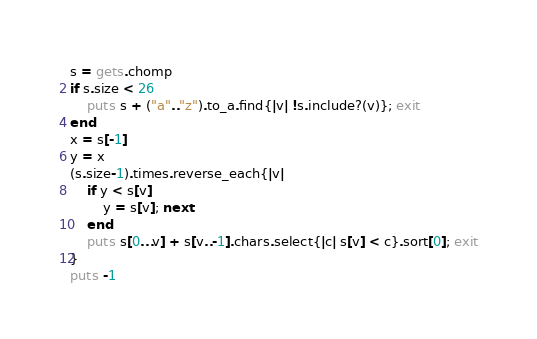<code> <loc_0><loc_0><loc_500><loc_500><_Ruby_>s = gets.chomp
if s.size < 26
    puts s + ("a".."z").to_a.find{|v| !s.include?(v)}; exit
end
x = s[-1]
y = x
(s.size-1).times.reverse_each{|v|
    if y < s[v]
        y = s[v]; next
    end
    puts s[0...v] + s[v..-1].chars.select{|c| s[v] < c}.sort[0]; exit
}
puts -1</code> 